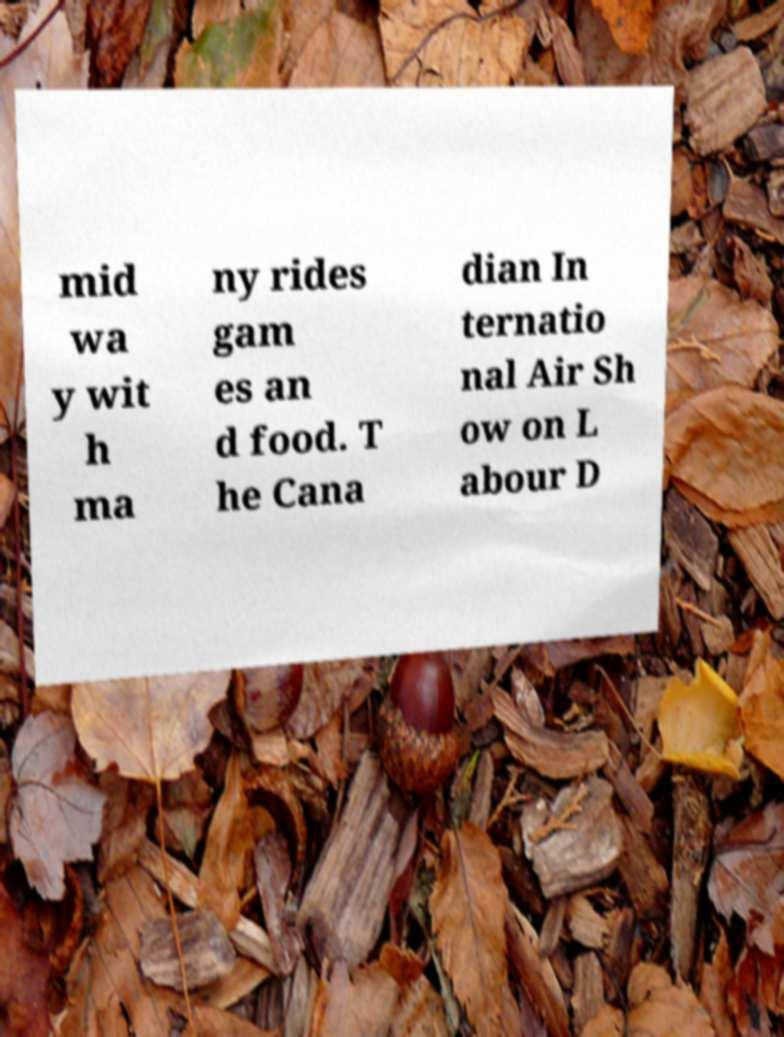Please identify and transcribe the text found in this image. mid wa y wit h ma ny rides gam es an d food. T he Cana dian In ternatio nal Air Sh ow on L abour D 